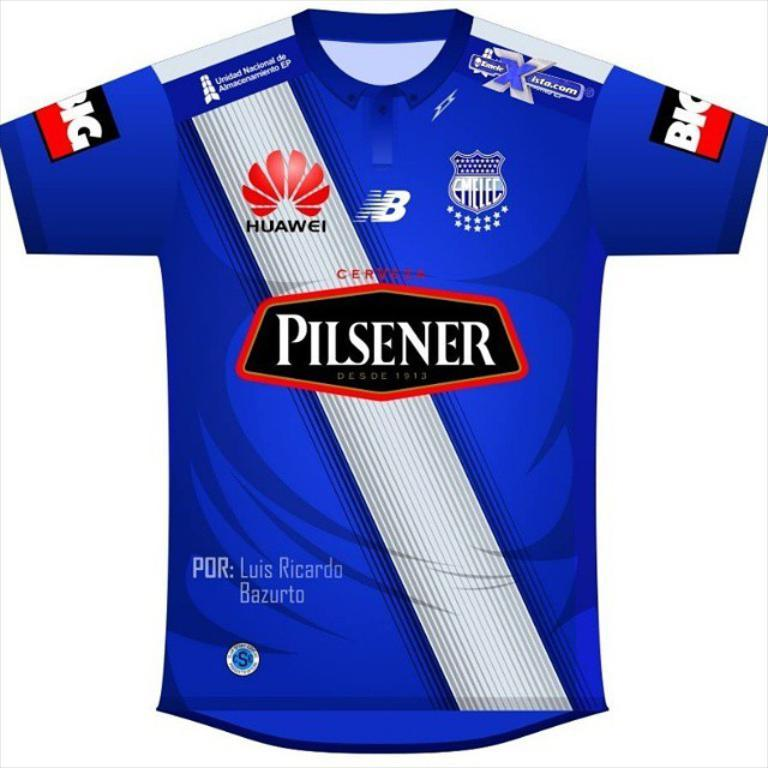<image>
Offer a succinct explanation of the picture presented. Blue soccer jersey which says Pilsener on the front. 